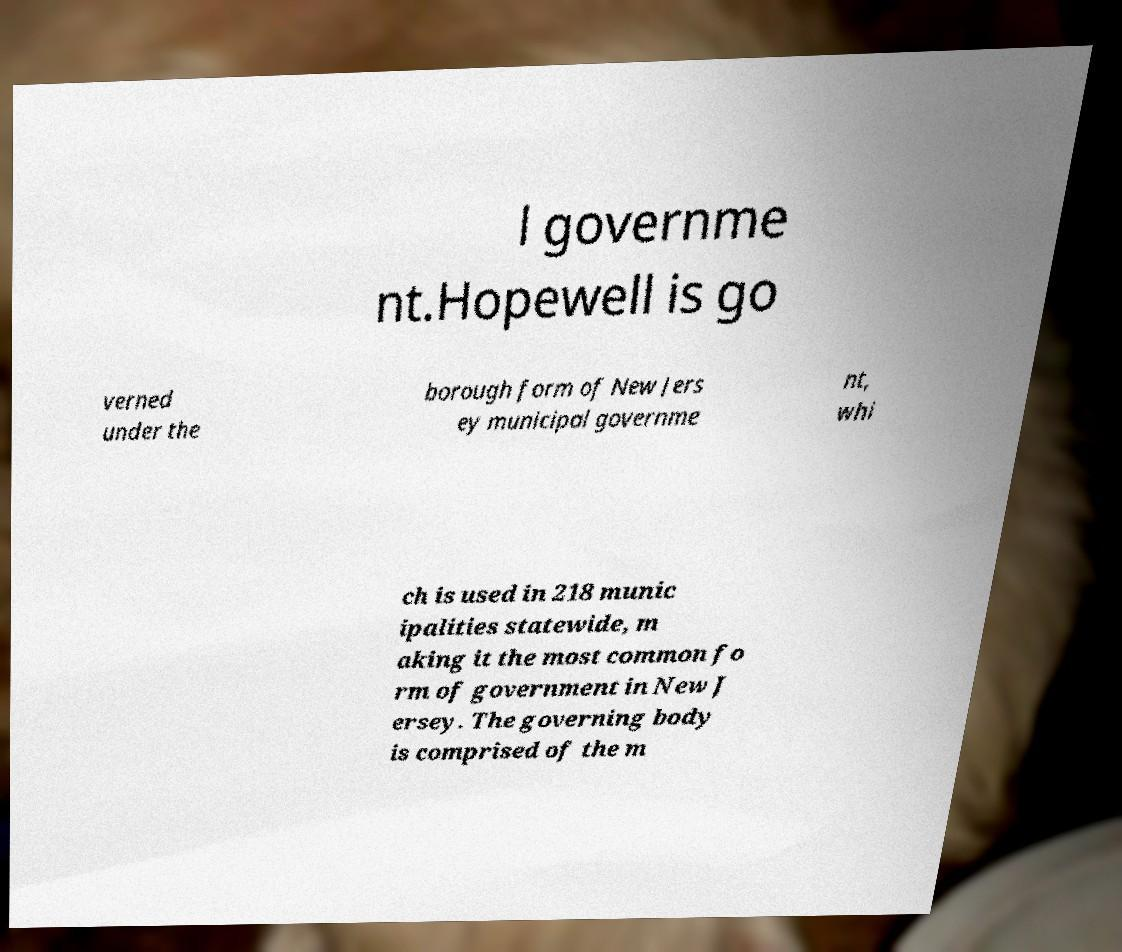What messages or text are displayed in this image? I need them in a readable, typed format. l governme nt.Hopewell is go verned under the borough form of New Jers ey municipal governme nt, whi ch is used in 218 munic ipalities statewide, m aking it the most common fo rm of government in New J ersey. The governing body is comprised of the m 